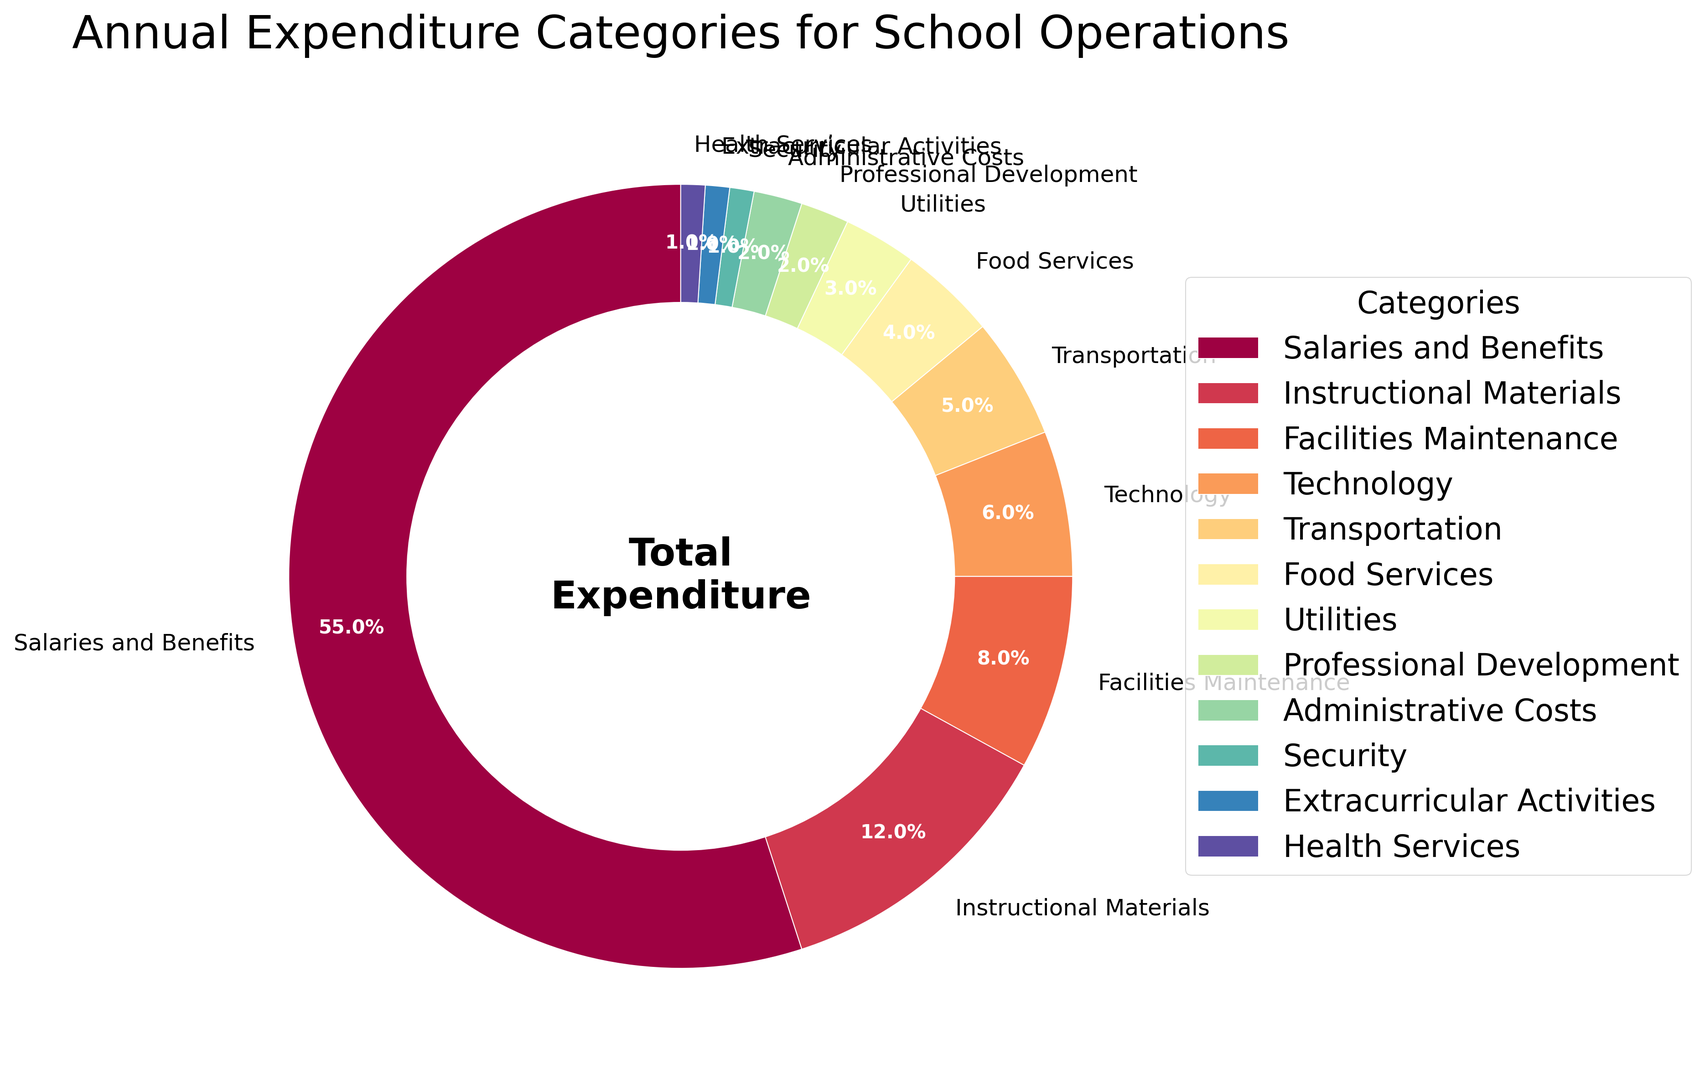What is the largest category of expenditure? The largest category of expenditure can be determined by finding the slice with the highest percentage on the pie chart. "Salaries and Benefits" have the highest percentage at 55%.
Answer: Salaries and Benefits What is the combined percentage of 'Technology' and 'Facilities Maintenance'? Add the percentages of 'Technology' (6%) and 'Facilities Maintenance' (8%). The combined percentage is 6 + 8 = 14%.
Answer: 14% Which category has a smaller percentage, 'Utilities' or 'Transportation'? Compare the percentages of 'Utilities' (3%) and 'Transportation' (5%). 'Utilities' have a smaller percentage.
Answer: Utilities What is the percentage difference between 'Instructional Materials' and 'Food Services'? Subtract the percentage of 'Food Services' (4%) from 'Instructional Materials' (12%). The difference is 12 - 4 = 8%.
Answer: 8% How many categories have a percentage of 2% or less? Count the categories with percentages 2% or less: 'Professional Development' (2%), 'Administrative Costs' (2%), 'Security' (1%), 'Extracurricular Activities' (1%), and 'Health Services' (1%). There are 5 categories in total.
Answer: 5 Which category is represented by the smallest slice in the pie chart? Find the category with the smallest percentage. Three categories ('Security', 'Extracurricular Activities', and 'Health Services') each have 1%, but all are of equal smallest size. Any of these could be correct.
Answer: Security (also acceptable: Extracurricular Activities or Health Services) What color is used for the 'Salaries and Benefits' category? Observe the color used for the 'Salaries and Benefits' slice on the pie chart. It is typically the first color in a sequential color map, often in this context, it could be a prominent color like red or orange.
Answer: (specific color based on chart visualization, e.g., red/orange) Which is greater, the percentage of 'Extracurricular Activities' or 'Professional Development'? Compare the percentages of 'Extracurricular Activities' (1%) and 'Professional Development' (2%). 'Professional Development' has a greater percentage.
Answer: Professional Development What is the total percentage of categories related to 'student services' (i.e., 'Food Services', 'Health Services', 'Extracurricular Activities')? Add the percentages of 'Food Services' (4%), 'Health Services' (1%), and 'Extracurricular Activities' (1%). The total is 4 + 1 + 1 = 6%.
Answer: 6% Which category has the second-largest slice in the pie chart? Identify the category with the second-highest percentage. 'Instructional Materials' have the second-largest percentage at 12%.
Answer: Instructional Materials 